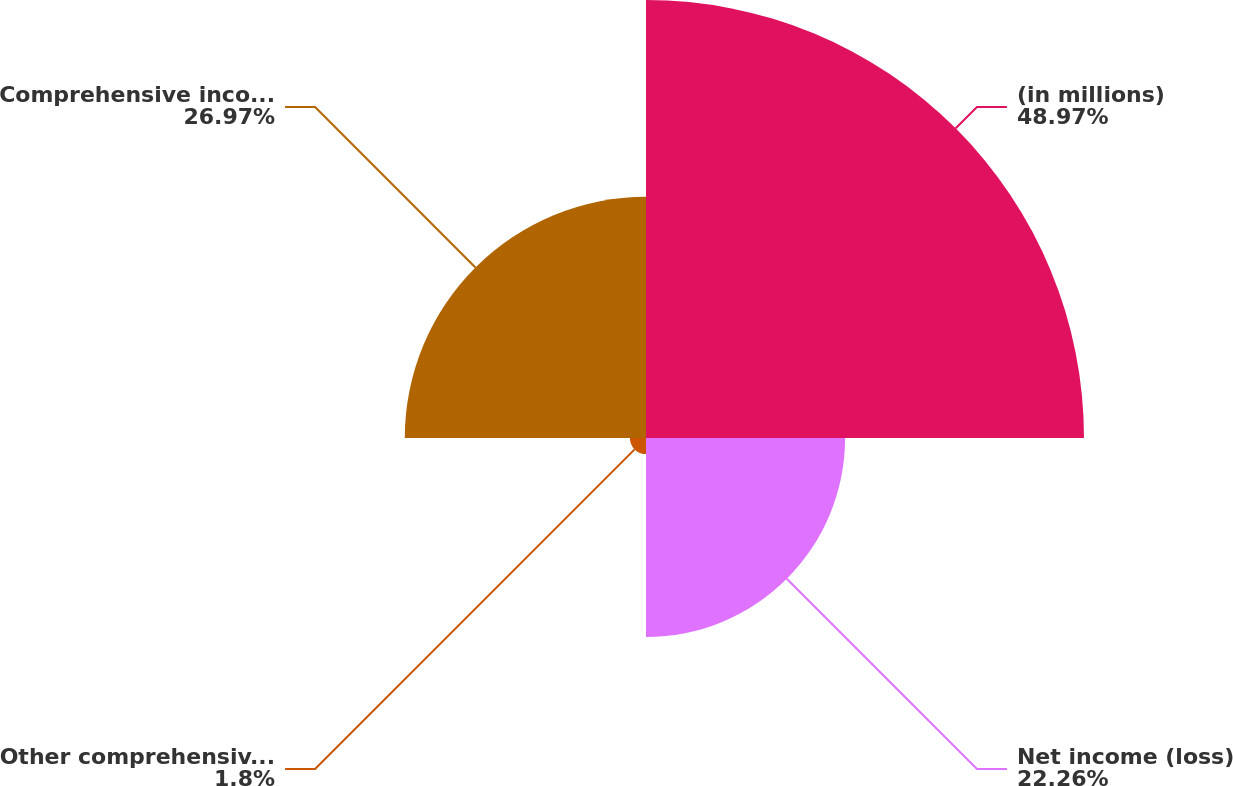<chart> <loc_0><loc_0><loc_500><loc_500><pie_chart><fcel>(in millions)<fcel>Net income (loss)<fcel>Other comprehensive income<fcel>Comprehensive income (loss)<nl><fcel>48.97%<fcel>22.26%<fcel>1.8%<fcel>26.97%<nl></chart> 